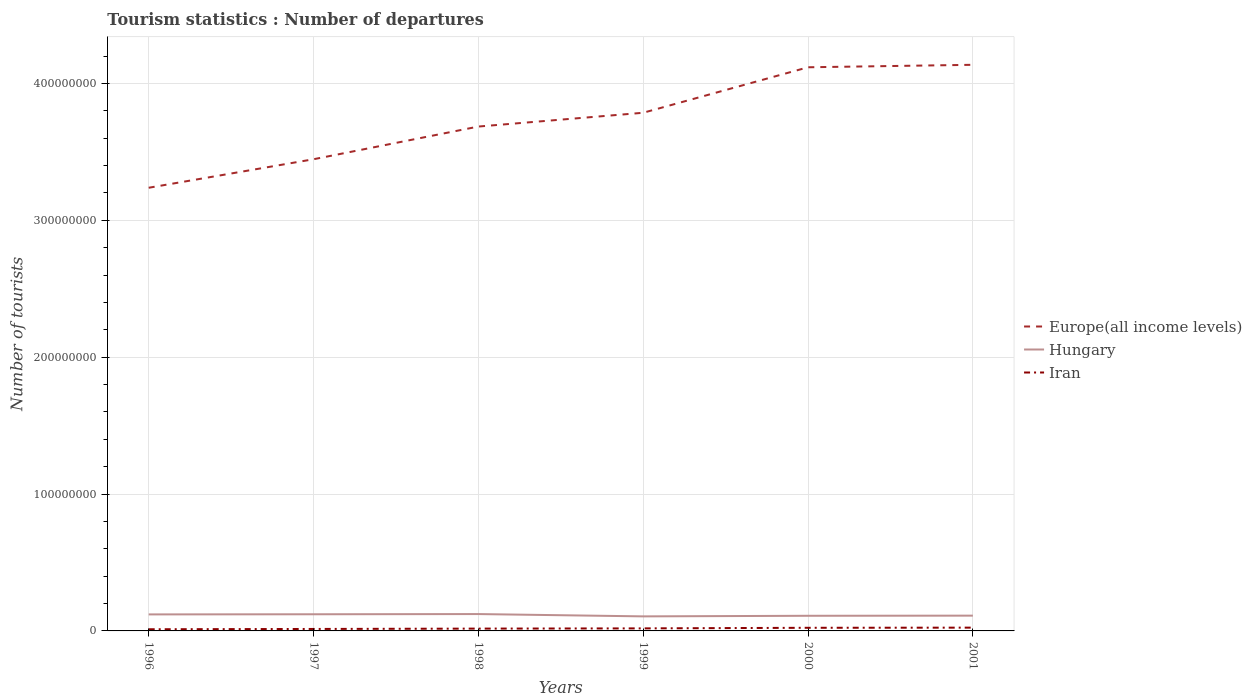How many different coloured lines are there?
Offer a very short reply. 3. Across all years, what is the maximum number of tourist departures in Iran?
Offer a terse response. 1.22e+06. In which year was the number of tourist departures in Iran maximum?
Your answer should be very brief. 1996. What is the total number of tourist departures in Hungary in the graph?
Keep it short and to the point. -4.43e+05. What is the difference between the highest and the second highest number of tourist departures in Hungary?
Offer a terse response. 1.70e+06. How many lines are there?
Ensure brevity in your answer.  3. How many years are there in the graph?
Your answer should be very brief. 6. What is the difference between two consecutive major ticks on the Y-axis?
Give a very brief answer. 1.00e+08. Are the values on the major ticks of Y-axis written in scientific E-notation?
Your answer should be compact. No. Does the graph contain any zero values?
Offer a very short reply. No. Does the graph contain grids?
Your answer should be compact. Yes. How are the legend labels stacked?
Your answer should be compact. Vertical. What is the title of the graph?
Keep it short and to the point. Tourism statistics : Number of departures. Does "Morocco" appear as one of the legend labels in the graph?
Provide a succinct answer. No. What is the label or title of the Y-axis?
Give a very brief answer. Number of tourists. What is the Number of tourists in Europe(all income levels) in 1996?
Your answer should be compact. 3.24e+08. What is the Number of tourists of Hungary in 1996?
Your response must be concise. 1.21e+07. What is the Number of tourists of Iran in 1996?
Provide a succinct answer. 1.22e+06. What is the Number of tourists in Europe(all income levels) in 1997?
Offer a terse response. 3.45e+08. What is the Number of tourists in Hungary in 1997?
Provide a succinct answer. 1.22e+07. What is the Number of tourists in Iran in 1997?
Make the answer very short. 1.43e+06. What is the Number of tourists of Europe(all income levels) in 1998?
Your answer should be compact. 3.68e+08. What is the Number of tourists of Hungary in 1998?
Offer a very short reply. 1.23e+07. What is the Number of tourists in Iran in 1998?
Offer a very short reply. 1.69e+06. What is the Number of tourists in Europe(all income levels) in 1999?
Make the answer very short. 3.79e+08. What is the Number of tourists in Hungary in 1999?
Ensure brevity in your answer.  1.06e+07. What is the Number of tourists of Iran in 1999?
Offer a terse response. 1.86e+06. What is the Number of tourists of Europe(all income levels) in 2000?
Offer a terse response. 4.12e+08. What is the Number of tourists in Hungary in 2000?
Offer a terse response. 1.11e+07. What is the Number of tourists in Iran in 2000?
Offer a very short reply. 2.29e+06. What is the Number of tourists of Europe(all income levels) in 2001?
Provide a short and direct response. 4.14e+08. What is the Number of tourists of Hungary in 2001?
Make the answer very short. 1.12e+07. What is the Number of tourists of Iran in 2001?
Your response must be concise. 2.40e+06. Across all years, what is the maximum Number of tourists of Europe(all income levels)?
Offer a very short reply. 4.14e+08. Across all years, what is the maximum Number of tourists of Hungary?
Your response must be concise. 1.23e+07. Across all years, what is the maximum Number of tourists in Iran?
Provide a succinct answer. 2.40e+06. Across all years, what is the minimum Number of tourists of Europe(all income levels)?
Offer a very short reply. 3.24e+08. Across all years, what is the minimum Number of tourists of Hungary?
Your response must be concise. 1.06e+07. Across all years, what is the minimum Number of tourists in Iran?
Give a very brief answer. 1.22e+06. What is the total Number of tourists in Europe(all income levels) in the graph?
Offer a terse response. 2.24e+09. What is the total Number of tourists of Hungary in the graph?
Your answer should be compact. 6.94e+07. What is the total Number of tourists in Iran in the graph?
Offer a terse response. 1.09e+07. What is the difference between the Number of tourists in Europe(all income levels) in 1996 and that in 1997?
Provide a short and direct response. -2.08e+07. What is the difference between the Number of tourists in Hungary in 1996 and that in 1997?
Offer a terse response. -1.09e+05. What is the difference between the Number of tourists of Iran in 1996 and that in 1997?
Your answer should be very brief. -2.15e+05. What is the difference between the Number of tourists in Europe(all income levels) in 1996 and that in 1998?
Your response must be concise. -4.47e+07. What is the difference between the Number of tourists of Hungary in 1996 and that in 1998?
Make the answer very short. -2.53e+05. What is the difference between the Number of tourists of Iran in 1996 and that in 1998?
Keep it short and to the point. -4.72e+05. What is the difference between the Number of tourists of Europe(all income levels) in 1996 and that in 1999?
Provide a short and direct response. -5.48e+07. What is the difference between the Number of tourists of Hungary in 1996 and that in 1999?
Your response must be concise. 1.44e+06. What is the difference between the Number of tourists of Iran in 1996 and that in 1999?
Keep it short and to the point. -6.38e+05. What is the difference between the Number of tourists in Europe(all income levels) in 1996 and that in 2000?
Ensure brevity in your answer.  -8.80e+07. What is the difference between the Number of tourists in Hungary in 1996 and that in 2000?
Make the answer very short. 9.99e+05. What is the difference between the Number of tourists of Iran in 1996 and that in 2000?
Ensure brevity in your answer.  -1.07e+06. What is the difference between the Number of tourists of Europe(all income levels) in 1996 and that in 2001?
Provide a short and direct response. -8.98e+07. What is the difference between the Number of tourists of Hungary in 1996 and that in 2001?
Your answer should be compact. 8.97e+05. What is the difference between the Number of tourists of Iran in 1996 and that in 2001?
Your answer should be very brief. -1.18e+06. What is the difference between the Number of tourists of Europe(all income levels) in 1997 and that in 1998?
Your response must be concise. -2.39e+07. What is the difference between the Number of tourists of Hungary in 1997 and that in 1998?
Offer a terse response. -1.44e+05. What is the difference between the Number of tourists of Iran in 1997 and that in 1998?
Offer a terse response. -2.57e+05. What is the difference between the Number of tourists of Europe(all income levels) in 1997 and that in 1999?
Provide a succinct answer. -3.40e+07. What is the difference between the Number of tourists of Hungary in 1997 and that in 1999?
Your response must be concise. 1.55e+06. What is the difference between the Number of tourists in Iran in 1997 and that in 1999?
Keep it short and to the point. -4.23e+05. What is the difference between the Number of tourists of Europe(all income levels) in 1997 and that in 2000?
Keep it short and to the point. -6.72e+07. What is the difference between the Number of tourists of Hungary in 1997 and that in 2000?
Give a very brief answer. 1.11e+06. What is the difference between the Number of tourists in Iran in 1997 and that in 2000?
Offer a terse response. -8.53e+05. What is the difference between the Number of tourists in Europe(all income levels) in 1997 and that in 2001?
Ensure brevity in your answer.  -6.90e+07. What is the difference between the Number of tourists in Hungary in 1997 and that in 2001?
Provide a short and direct response. 1.01e+06. What is the difference between the Number of tourists in Iran in 1997 and that in 2001?
Provide a succinct answer. -9.67e+05. What is the difference between the Number of tourists of Europe(all income levels) in 1998 and that in 1999?
Keep it short and to the point. -1.01e+07. What is the difference between the Number of tourists in Hungary in 1998 and that in 1999?
Offer a terse response. 1.70e+06. What is the difference between the Number of tourists in Iran in 1998 and that in 1999?
Provide a succinct answer. -1.66e+05. What is the difference between the Number of tourists of Europe(all income levels) in 1998 and that in 2000?
Offer a terse response. -4.33e+07. What is the difference between the Number of tourists in Hungary in 1998 and that in 2000?
Provide a short and direct response. 1.25e+06. What is the difference between the Number of tourists in Iran in 1998 and that in 2000?
Your answer should be compact. -5.96e+05. What is the difference between the Number of tourists in Europe(all income levels) in 1998 and that in 2001?
Provide a short and direct response. -4.51e+07. What is the difference between the Number of tourists in Hungary in 1998 and that in 2001?
Make the answer very short. 1.15e+06. What is the difference between the Number of tourists in Iran in 1998 and that in 2001?
Your response must be concise. -7.10e+05. What is the difference between the Number of tourists of Europe(all income levels) in 1999 and that in 2000?
Make the answer very short. -3.32e+07. What is the difference between the Number of tourists of Hungary in 1999 and that in 2000?
Give a very brief answer. -4.43e+05. What is the difference between the Number of tourists in Iran in 1999 and that in 2000?
Offer a terse response. -4.30e+05. What is the difference between the Number of tourists in Europe(all income levels) in 1999 and that in 2001?
Your response must be concise. -3.50e+07. What is the difference between the Number of tourists in Hungary in 1999 and that in 2001?
Your response must be concise. -5.45e+05. What is the difference between the Number of tourists in Iran in 1999 and that in 2001?
Make the answer very short. -5.44e+05. What is the difference between the Number of tourists in Europe(all income levels) in 2000 and that in 2001?
Provide a succinct answer. -1.81e+06. What is the difference between the Number of tourists of Hungary in 2000 and that in 2001?
Your answer should be compact. -1.02e+05. What is the difference between the Number of tourists in Iran in 2000 and that in 2001?
Make the answer very short. -1.14e+05. What is the difference between the Number of tourists in Europe(all income levels) in 1996 and the Number of tourists in Hungary in 1997?
Make the answer very short. 3.12e+08. What is the difference between the Number of tourists of Europe(all income levels) in 1996 and the Number of tourists of Iran in 1997?
Your response must be concise. 3.22e+08. What is the difference between the Number of tourists of Hungary in 1996 and the Number of tourists of Iran in 1997?
Provide a succinct answer. 1.06e+07. What is the difference between the Number of tourists in Europe(all income levels) in 1996 and the Number of tourists in Hungary in 1998?
Your answer should be very brief. 3.11e+08. What is the difference between the Number of tourists of Europe(all income levels) in 1996 and the Number of tourists of Iran in 1998?
Offer a terse response. 3.22e+08. What is the difference between the Number of tourists of Hungary in 1996 and the Number of tourists of Iran in 1998?
Your answer should be compact. 1.04e+07. What is the difference between the Number of tourists in Europe(all income levels) in 1996 and the Number of tourists in Hungary in 1999?
Your response must be concise. 3.13e+08. What is the difference between the Number of tourists of Europe(all income levels) in 1996 and the Number of tourists of Iran in 1999?
Provide a succinct answer. 3.22e+08. What is the difference between the Number of tourists in Hungary in 1996 and the Number of tourists in Iran in 1999?
Provide a succinct answer. 1.02e+07. What is the difference between the Number of tourists in Europe(all income levels) in 1996 and the Number of tourists in Hungary in 2000?
Your answer should be compact. 3.13e+08. What is the difference between the Number of tourists of Europe(all income levels) in 1996 and the Number of tourists of Iran in 2000?
Your answer should be very brief. 3.21e+08. What is the difference between the Number of tourists of Hungary in 1996 and the Number of tourists of Iran in 2000?
Provide a short and direct response. 9.78e+06. What is the difference between the Number of tourists in Europe(all income levels) in 1996 and the Number of tourists in Hungary in 2001?
Offer a very short reply. 3.13e+08. What is the difference between the Number of tourists of Europe(all income levels) in 1996 and the Number of tourists of Iran in 2001?
Provide a succinct answer. 3.21e+08. What is the difference between the Number of tourists in Hungary in 1996 and the Number of tourists in Iran in 2001?
Provide a succinct answer. 9.66e+06. What is the difference between the Number of tourists in Europe(all income levels) in 1997 and the Number of tourists in Hungary in 1998?
Offer a terse response. 3.32e+08. What is the difference between the Number of tourists in Europe(all income levels) in 1997 and the Number of tourists in Iran in 1998?
Your answer should be compact. 3.43e+08. What is the difference between the Number of tourists in Hungary in 1997 and the Number of tourists in Iran in 1998?
Your response must be concise. 1.05e+07. What is the difference between the Number of tourists in Europe(all income levels) in 1997 and the Number of tourists in Hungary in 1999?
Provide a succinct answer. 3.34e+08. What is the difference between the Number of tourists in Europe(all income levels) in 1997 and the Number of tourists in Iran in 1999?
Keep it short and to the point. 3.43e+08. What is the difference between the Number of tourists in Hungary in 1997 and the Number of tourists in Iran in 1999?
Offer a very short reply. 1.03e+07. What is the difference between the Number of tourists in Europe(all income levels) in 1997 and the Number of tourists in Hungary in 2000?
Your answer should be compact. 3.34e+08. What is the difference between the Number of tourists in Europe(all income levels) in 1997 and the Number of tourists in Iran in 2000?
Offer a very short reply. 3.42e+08. What is the difference between the Number of tourists of Hungary in 1997 and the Number of tourists of Iran in 2000?
Your response must be concise. 9.89e+06. What is the difference between the Number of tourists of Europe(all income levels) in 1997 and the Number of tourists of Hungary in 2001?
Ensure brevity in your answer.  3.33e+08. What is the difference between the Number of tourists in Europe(all income levels) in 1997 and the Number of tourists in Iran in 2001?
Your answer should be compact. 3.42e+08. What is the difference between the Number of tourists of Hungary in 1997 and the Number of tourists of Iran in 2001?
Your answer should be very brief. 9.77e+06. What is the difference between the Number of tourists in Europe(all income levels) in 1998 and the Number of tourists in Hungary in 1999?
Your response must be concise. 3.58e+08. What is the difference between the Number of tourists of Europe(all income levels) in 1998 and the Number of tourists of Iran in 1999?
Your answer should be compact. 3.67e+08. What is the difference between the Number of tourists in Hungary in 1998 and the Number of tourists in Iran in 1999?
Keep it short and to the point. 1.05e+07. What is the difference between the Number of tourists of Europe(all income levels) in 1998 and the Number of tourists of Hungary in 2000?
Your answer should be compact. 3.57e+08. What is the difference between the Number of tourists of Europe(all income levels) in 1998 and the Number of tourists of Iran in 2000?
Provide a short and direct response. 3.66e+08. What is the difference between the Number of tourists of Hungary in 1998 and the Number of tourists of Iran in 2000?
Keep it short and to the point. 1.00e+07. What is the difference between the Number of tourists in Europe(all income levels) in 1998 and the Number of tourists in Hungary in 2001?
Provide a short and direct response. 3.57e+08. What is the difference between the Number of tourists of Europe(all income levels) in 1998 and the Number of tourists of Iran in 2001?
Your answer should be compact. 3.66e+08. What is the difference between the Number of tourists in Hungary in 1998 and the Number of tourists in Iran in 2001?
Make the answer very short. 9.92e+06. What is the difference between the Number of tourists of Europe(all income levels) in 1999 and the Number of tourists of Hungary in 2000?
Ensure brevity in your answer.  3.68e+08. What is the difference between the Number of tourists of Europe(all income levels) in 1999 and the Number of tourists of Iran in 2000?
Ensure brevity in your answer.  3.76e+08. What is the difference between the Number of tourists of Hungary in 1999 and the Number of tourists of Iran in 2000?
Your response must be concise. 8.34e+06. What is the difference between the Number of tourists of Europe(all income levels) in 1999 and the Number of tourists of Hungary in 2001?
Make the answer very short. 3.67e+08. What is the difference between the Number of tourists in Europe(all income levels) in 1999 and the Number of tourists in Iran in 2001?
Make the answer very short. 3.76e+08. What is the difference between the Number of tourists in Hungary in 1999 and the Number of tourists in Iran in 2001?
Your answer should be compact. 8.22e+06. What is the difference between the Number of tourists in Europe(all income levels) in 2000 and the Number of tourists in Hungary in 2001?
Offer a terse response. 4.01e+08. What is the difference between the Number of tourists in Europe(all income levels) in 2000 and the Number of tourists in Iran in 2001?
Your answer should be compact. 4.09e+08. What is the difference between the Number of tourists in Hungary in 2000 and the Number of tourists in Iran in 2001?
Your answer should be compact. 8.66e+06. What is the average Number of tourists of Europe(all income levels) per year?
Provide a succinct answer. 3.73e+08. What is the average Number of tourists of Hungary per year?
Keep it short and to the point. 1.16e+07. What is the average Number of tourists in Iran per year?
Offer a very short reply. 1.81e+06. In the year 1996, what is the difference between the Number of tourists of Europe(all income levels) and Number of tourists of Hungary?
Your answer should be very brief. 3.12e+08. In the year 1996, what is the difference between the Number of tourists in Europe(all income levels) and Number of tourists in Iran?
Offer a terse response. 3.23e+08. In the year 1996, what is the difference between the Number of tourists of Hungary and Number of tourists of Iran?
Provide a short and direct response. 1.08e+07. In the year 1997, what is the difference between the Number of tourists in Europe(all income levels) and Number of tourists in Hungary?
Provide a succinct answer. 3.32e+08. In the year 1997, what is the difference between the Number of tourists of Europe(all income levels) and Number of tourists of Iran?
Your answer should be compact. 3.43e+08. In the year 1997, what is the difference between the Number of tourists in Hungary and Number of tourists in Iran?
Your answer should be compact. 1.07e+07. In the year 1998, what is the difference between the Number of tourists of Europe(all income levels) and Number of tourists of Hungary?
Offer a very short reply. 3.56e+08. In the year 1998, what is the difference between the Number of tourists of Europe(all income levels) and Number of tourists of Iran?
Make the answer very short. 3.67e+08. In the year 1998, what is the difference between the Number of tourists of Hungary and Number of tourists of Iran?
Ensure brevity in your answer.  1.06e+07. In the year 1999, what is the difference between the Number of tourists of Europe(all income levels) and Number of tourists of Hungary?
Keep it short and to the point. 3.68e+08. In the year 1999, what is the difference between the Number of tourists of Europe(all income levels) and Number of tourists of Iran?
Offer a very short reply. 3.77e+08. In the year 1999, what is the difference between the Number of tourists of Hungary and Number of tourists of Iran?
Offer a terse response. 8.77e+06. In the year 2000, what is the difference between the Number of tourists of Europe(all income levels) and Number of tourists of Hungary?
Your answer should be compact. 4.01e+08. In the year 2000, what is the difference between the Number of tourists of Europe(all income levels) and Number of tourists of Iran?
Make the answer very short. 4.10e+08. In the year 2000, what is the difference between the Number of tourists in Hungary and Number of tourists in Iran?
Keep it short and to the point. 8.78e+06. In the year 2001, what is the difference between the Number of tourists of Europe(all income levels) and Number of tourists of Hungary?
Make the answer very short. 4.02e+08. In the year 2001, what is the difference between the Number of tourists in Europe(all income levels) and Number of tourists in Iran?
Make the answer very short. 4.11e+08. In the year 2001, what is the difference between the Number of tourists of Hungary and Number of tourists of Iran?
Your answer should be compact. 8.77e+06. What is the ratio of the Number of tourists of Europe(all income levels) in 1996 to that in 1997?
Provide a short and direct response. 0.94. What is the ratio of the Number of tourists in Hungary in 1996 to that in 1997?
Ensure brevity in your answer.  0.99. What is the ratio of the Number of tourists of Europe(all income levels) in 1996 to that in 1998?
Offer a terse response. 0.88. What is the ratio of the Number of tourists of Hungary in 1996 to that in 1998?
Provide a short and direct response. 0.98. What is the ratio of the Number of tourists in Iran in 1996 to that in 1998?
Ensure brevity in your answer.  0.72. What is the ratio of the Number of tourists in Europe(all income levels) in 1996 to that in 1999?
Offer a terse response. 0.86. What is the ratio of the Number of tourists of Hungary in 1996 to that in 1999?
Your response must be concise. 1.14. What is the ratio of the Number of tourists of Iran in 1996 to that in 1999?
Offer a terse response. 0.66. What is the ratio of the Number of tourists of Europe(all income levels) in 1996 to that in 2000?
Provide a short and direct response. 0.79. What is the ratio of the Number of tourists in Hungary in 1996 to that in 2000?
Your response must be concise. 1.09. What is the ratio of the Number of tourists of Iran in 1996 to that in 2000?
Offer a terse response. 0.53. What is the ratio of the Number of tourists of Europe(all income levels) in 1996 to that in 2001?
Provide a short and direct response. 0.78. What is the ratio of the Number of tourists of Hungary in 1996 to that in 2001?
Offer a very short reply. 1.08. What is the ratio of the Number of tourists in Iran in 1996 to that in 2001?
Ensure brevity in your answer.  0.51. What is the ratio of the Number of tourists of Europe(all income levels) in 1997 to that in 1998?
Ensure brevity in your answer.  0.94. What is the ratio of the Number of tourists of Hungary in 1997 to that in 1998?
Offer a terse response. 0.99. What is the ratio of the Number of tourists in Iran in 1997 to that in 1998?
Your answer should be very brief. 0.85. What is the ratio of the Number of tourists of Europe(all income levels) in 1997 to that in 1999?
Give a very brief answer. 0.91. What is the ratio of the Number of tourists in Hungary in 1997 to that in 1999?
Provide a short and direct response. 1.15. What is the ratio of the Number of tourists in Iran in 1997 to that in 1999?
Your response must be concise. 0.77. What is the ratio of the Number of tourists of Europe(all income levels) in 1997 to that in 2000?
Your response must be concise. 0.84. What is the ratio of the Number of tourists of Hungary in 1997 to that in 2000?
Offer a terse response. 1.1. What is the ratio of the Number of tourists of Iran in 1997 to that in 2000?
Your answer should be very brief. 0.63. What is the ratio of the Number of tourists of Europe(all income levels) in 1997 to that in 2001?
Offer a terse response. 0.83. What is the ratio of the Number of tourists in Hungary in 1997 to that in 2001?
Provide a short and direct response. 1.09. What is the ratio of the Number of tourists in Iran in 1997 to that in 2001?
Offer a terse response. 0.6. What is the ratio of the Number of tourists of Europe(all income levels) in 1998 to that in 1999?
Provide a succinct answer. 0.97. What is the ratio of the Number of tourists of Hungary in 1998 to that in 1999?
Offer a terse response. 1.16. What is the ratio of the Number of tourists of Iran in 1998 to that in 1999?
Provide a short and direct response. 0.91. What is the ratio of the Number of tourists in Europe(all income levels) in 1998 to that in 2000?
Your response must be concise. 0.89. What is the ratio of the Number of tourists of Hungary in 1998 to that in 2000?
Offer a very short reply. 1.11. What is the ratio of the Number of tourists of Iran in 1998 to that in 2000?
Offer a very short reply. 0.74. What is the ratio of the Number of tourists of Europe(all income levels) in 1998 to that in 2001?
Your answer should be compact. 0.89. What is the ratio of the Number of tourists in Hungary in 1998 to that in 2001?
Offer a very short reply. 1.1. What is the ratio of the Number of tourists in Iran in 1998 to that in 2001?
Provide a succinct answer. 0.7. What is the ratio of the Number of tourists in Europe(all income levels) in 1999 to that in 2000?
Provide a short and direct response. 0.92. What is the ratio of the Number of tourists of Hungary in 1999 to that in 2000?
Ensure brevity in your answer.  0.96. What is the ratio of the Number of tourists of Iran in 1999 to that in 2000?
Ensure brevity in your answer.  0.81. What is the ratio of the Number of tourists in Europe(all income levels) in 1999 to that in 2001?
Keep it short and to the point. 0.92. What is the ratio of the Number of tourists of Hungary in 1999 to that in 2001?
Your response must be concise. 0.95. What is the ratio of the Number of tourists of Iran in 1999 to that in 2001?
Your response must be concise. 0.77. What is the ratio of the Number of tourists of Europe(all income levels) in 2000 to that in 2001?
Your answer should be very brief. 1. What is the ratio of the Number of tourists of Hungary in 2000 to that in 2001?
Your answer should be compact. 0.99. What is the ratio of the Number of tourists of Iran in 2000 to that in 2001?
Keep it short and to the point. 0.95. What is the difference between the highest and the second highest Number of tourists in Europe(all income levels)?
Keep it short and to the point. 1.81e+06. What is the difference between the highest and the second highest Number of tourists in Hungary?
Offer a very short reply. 1.44e+05. What is the difference between the highest and the second highest Number of tourists of Iran?
Offer a terse response. 1.14e+05. What is the difference between the highest and the lowest Number of tourists in Europe(all income levels)?
Provide a short and direct response. 8.98e+07. What is the difference between the highest and the lowest Number of tourists of Hungary?
Your response must be concise. 1.70e+06. What is the difference between the highest and the lowest Number of tourists of Iran?
Give a very brief answer. 1.18e+06. 